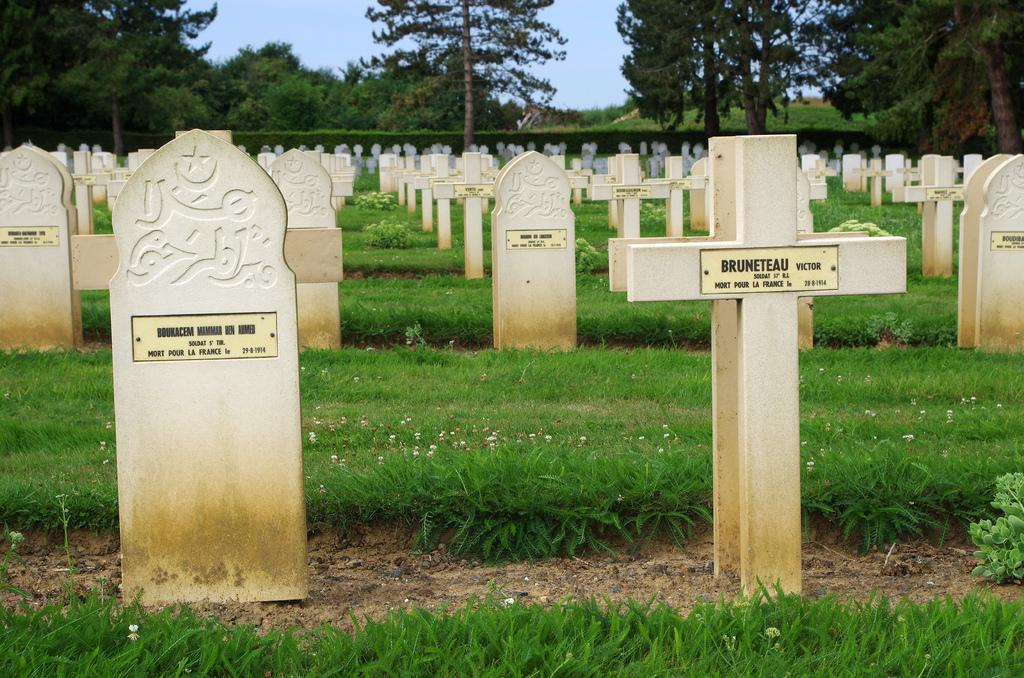What can be seen on the ground in the foreground of the image? There are headstones on the ground in the foreground of the image. What type of vegetation is visible in the foreground of the image? There is grass visible in the foreground of the image. What can be seen in the background of the image? There are trees and the sky visible in the background of the image. What type of smoke can be seen coming from the trees in the image? There is no smoke present in the image; it features headstones, grass, trees, and the sky. Can you hear the voice of the person buried under the headstones in the image? There is no voice present in the image, as it is a photograph and cannot capture sound. 